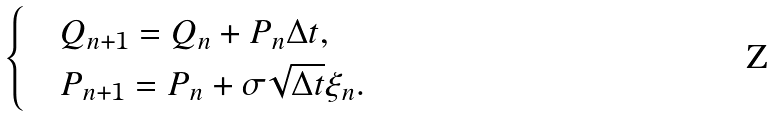<formula> <loc_0><loc_0><loc_500><loc_500>\begin{cases} & Q _ { n + 1 } = Q _ { n } + P _ { n } \Delta t , \\ & P _ { n + 1 } = P _ { n } + \sigma \sqrt { \Delta t } \xi _ { n } . \end{cases}</formula> 